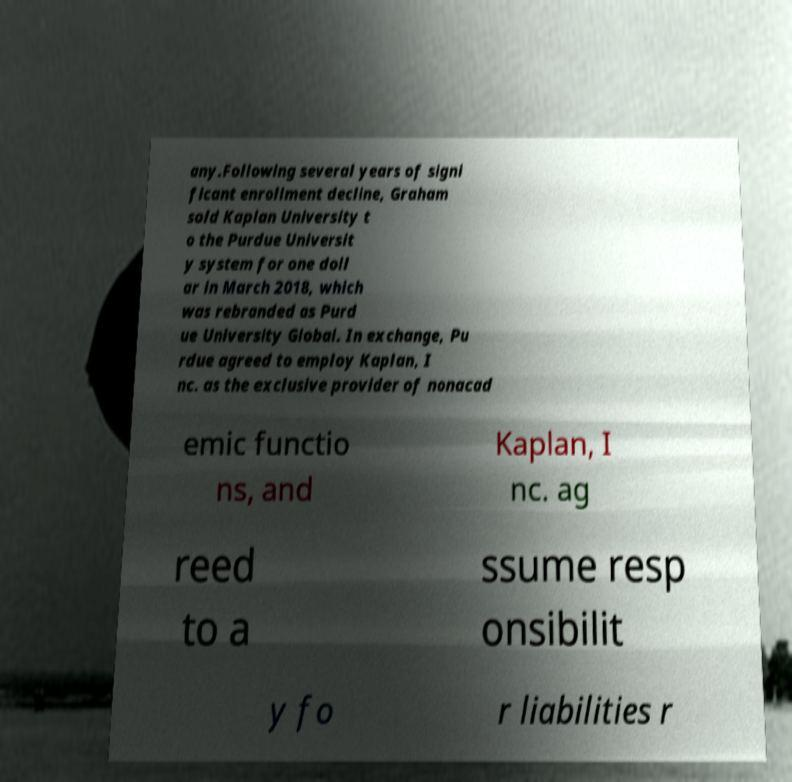Please read and relay the text visible in this image. What does it say? any.Following several years of signi ficant enrollment decline, Graham sold Kaplan University t o the Purdue Universit y system for one doll ar in March 2018, which was rebranded as Purd ue University Global. In exchange, Pu rdue agreed to employ Kaplan, I nc. as the exclusive provider of nonacad emic functio ns, and Kaplan, I nc. ag reed to a ssume resp onsibilit y fo r liabilities r 